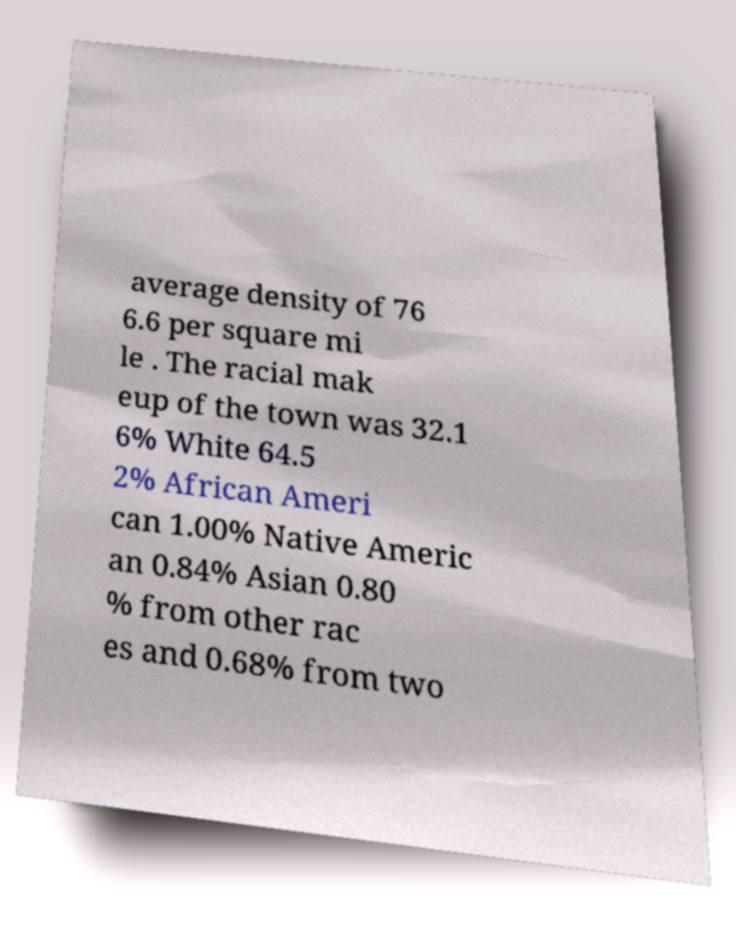Could you assist in decoding the text presented in this image and type it out clearly? average density of 76 6.6 per square mi le . The racial mak eup of the town was 32.1 6% White 64.5 2% African Ameri can 1.00% Native Americ an 0.84% Asian 0.80 % from other rac es and 0.68% from two 